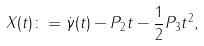<formula> <loc_0><loc_0><loc_500><loc_500>X ( t ) \colon = \dot { \gamma } ( t ) - P _ { 2 } t - \frac { 1 } { 2 } P _ { 3 } t ^ { 2 } ,</formula> 